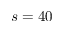Convert formula to latex. <formula><loc_0><loc_0><loc_500><loc_500>s = 4 0</formula> 